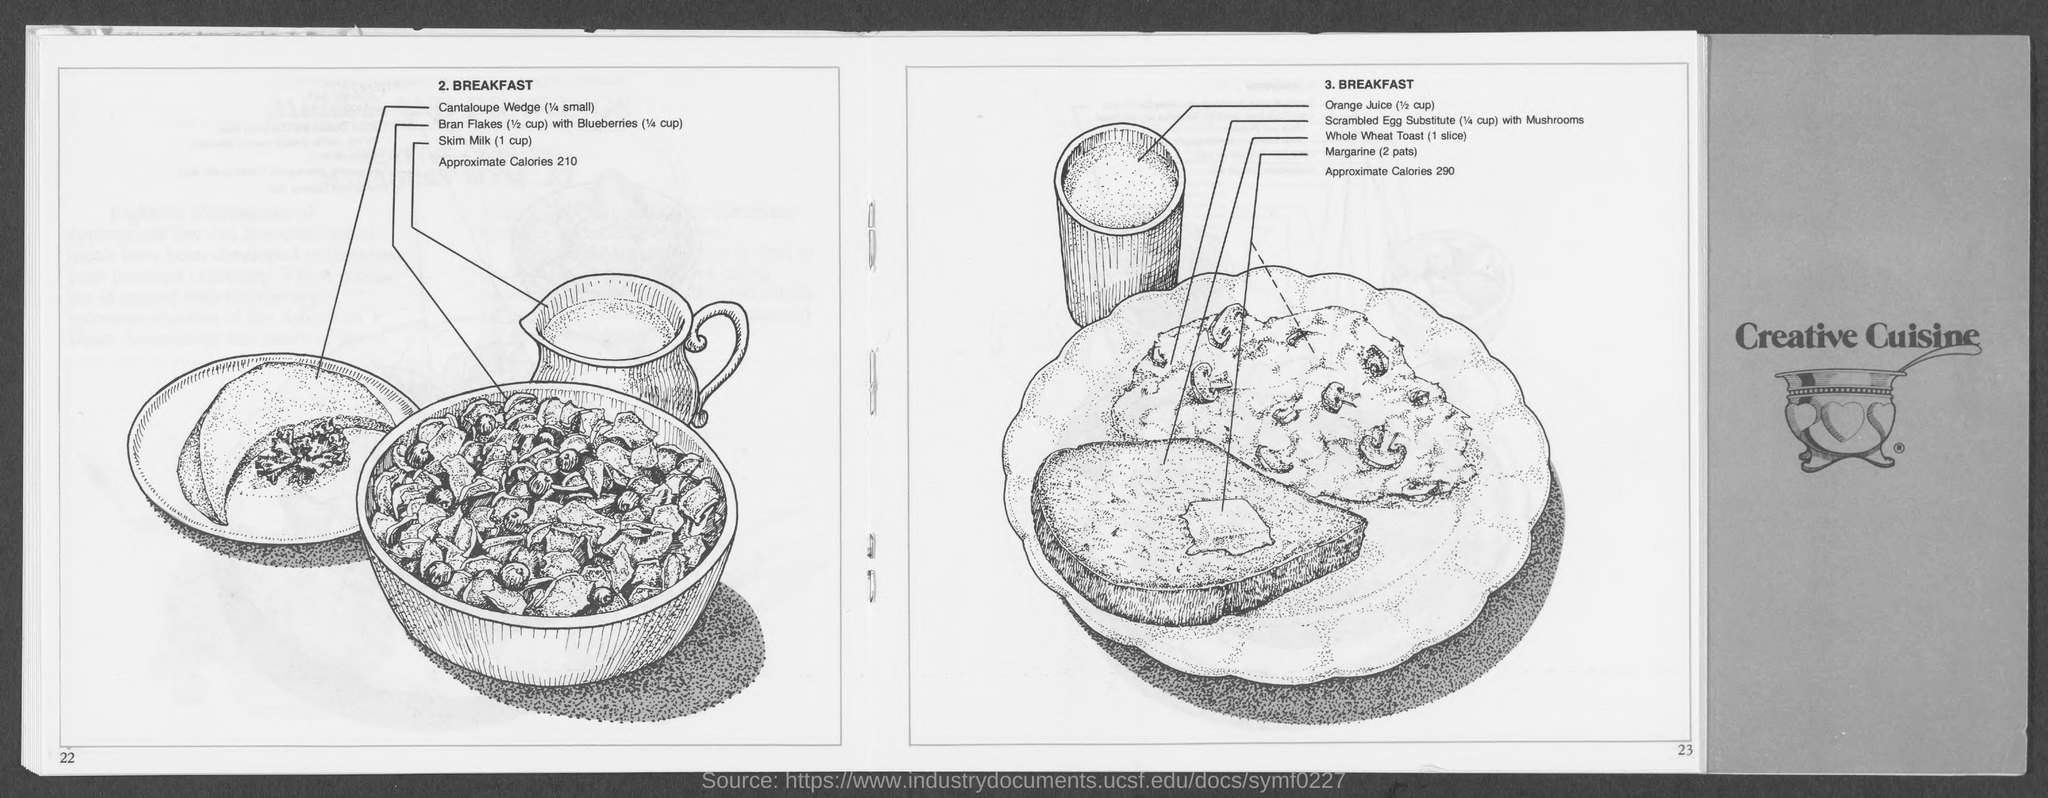What is the name on the book cover?
Offer a terse response. Creative Cuisine. What is the value of approximate calories of BREAKFAST under point number 2?
Make the answer very short. 210. What is the value of approximate calories of BREAKFAST under point number 3?
Your answer should be compact. 290. How many slices of whole wheat toast is recommended under point 3?
Offer a terse response. (1 slice). 